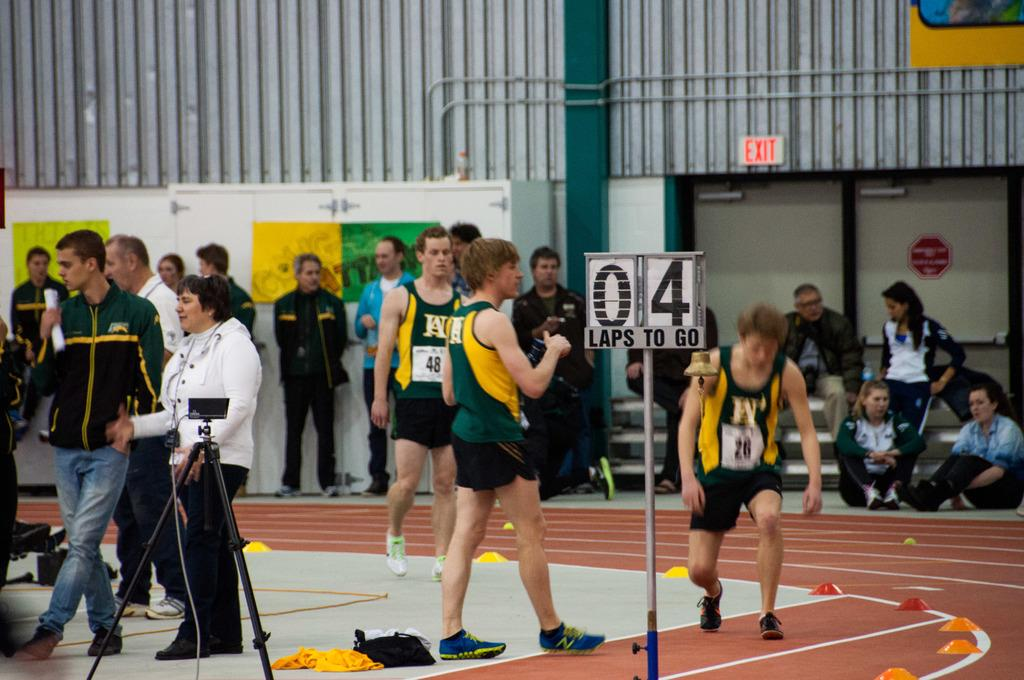<image>
Relay a brief, clear account of the picture shown. Athletes standing next to a pole which has a number 4 on it. 